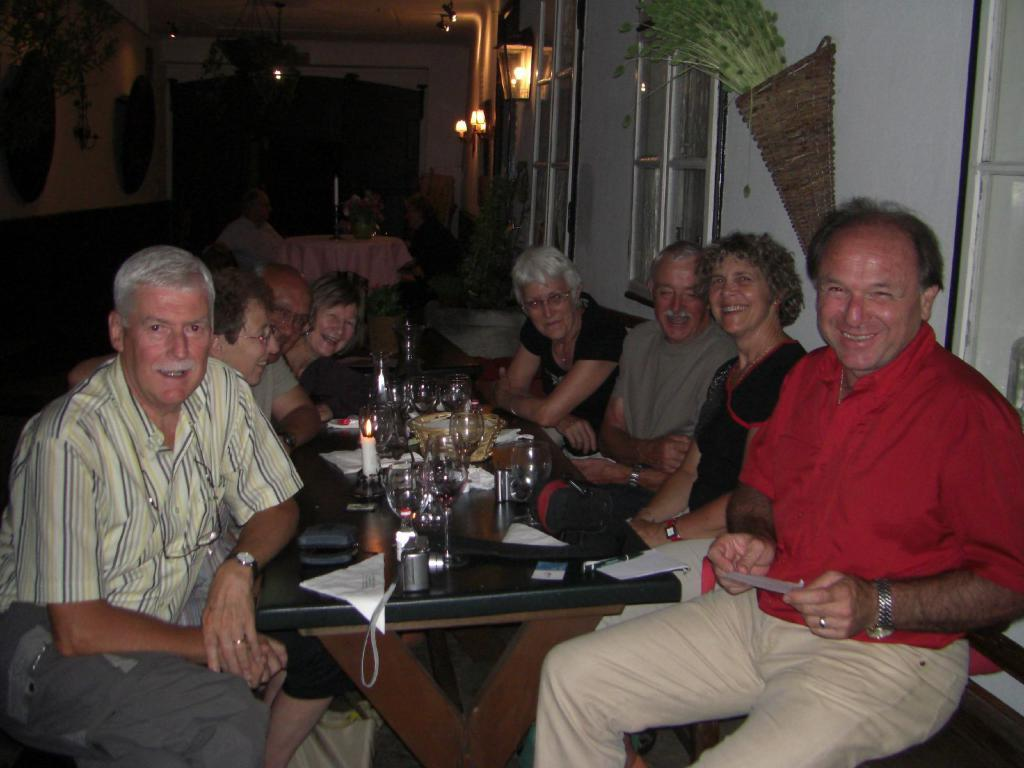What can be seen in the image that provides illumination? There is a light in the image. What type of structure is visible in the background? There is a wall in the image. What are the people in the image doing? There are people sitting on chairs in the image. What is on the table in the image? There are candles, glasses, and papers on the table. What type of screw is being used to hold the language in place in the image? There is no screw or language present in the image. What type of car can be seen in the image? There is no car present in the image. 